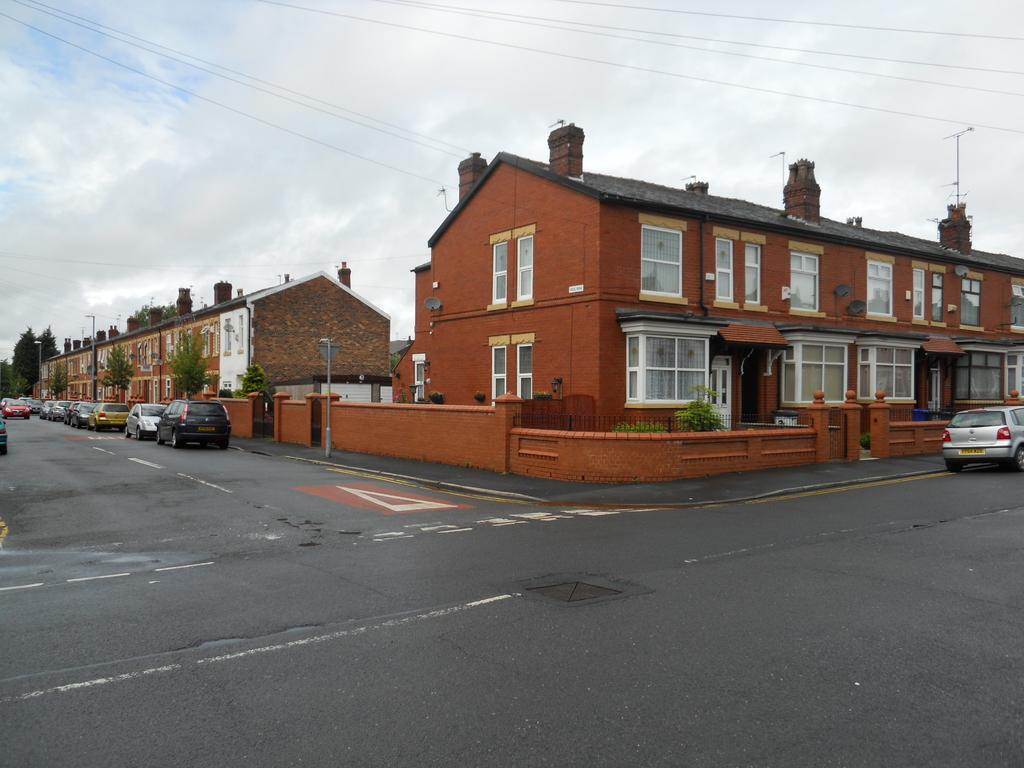What is the main feature of the image? There is a road in the image. What can be seen on the road? There are vehicles on the road. What type of buildings are present in the image? There are buildings with glass windows in the image. What infrastructure elements can be seen in the image? There are electrical lines in the image. What natural elements are present in the image? There are trees in the image. What is visible in the sky in the image? There are clouds in the sky in the image. How many deer can be seen running across the road in the image? There are no deer present in the image; it features a road with vehicles and buildings. What type of songs are being sung by the fireman in the image? There is no fireman or singing activity depicted in the image. 